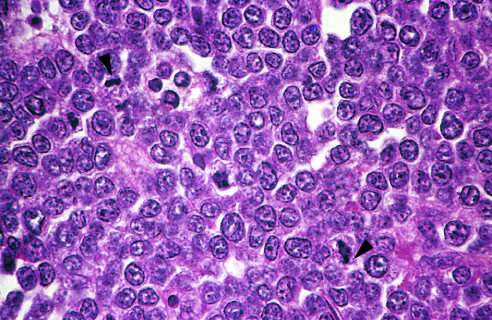s the starry sky pattern produced by interspersed, lightly staining, normal microphages?
Answer the question using a single word or phrase. Yes 